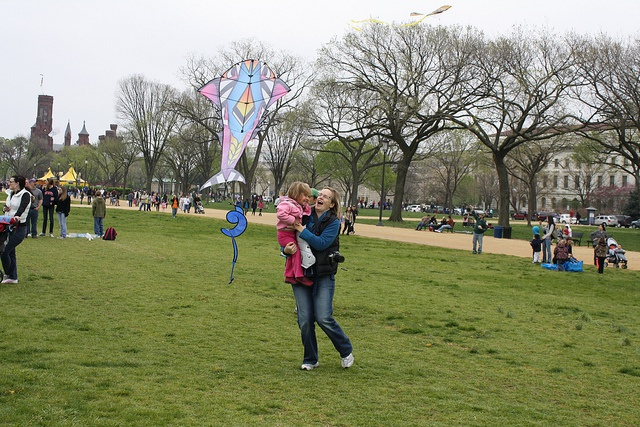Describe the objects in this image and their specific colors. I can see people in white, gray, black, darkgray, and darkgreen tones, people in white, black, gray, navy, and blue tones, kite in white, darkgray, lightblue, lavender, and pink tones, people in white, black, gray, lightgray, and darkgray tones, and people in white, maroon, brown, and lightpink tones in this image. 